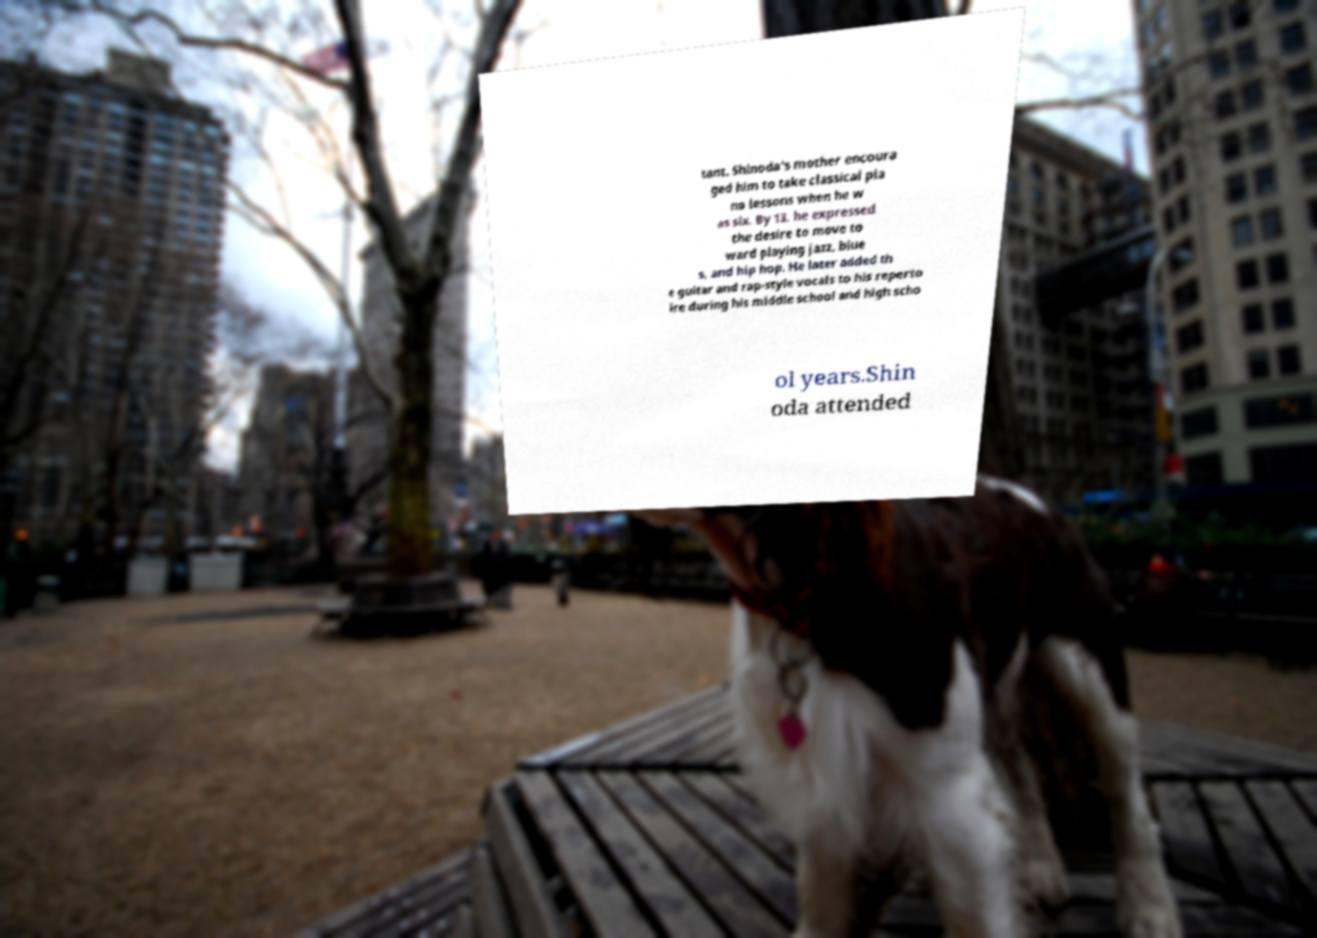For documentation purposes, I need the text within this image transcribed. Could you provide that? tant. Shinoda's mother encoura ged him to take classical pia no lessons when he w as six. By 13, he expressed the desire to move to ward playing jazz, blue s, and hip hop. He later added th e guitar and rap-style vocals to his reperto ire during his middle school and high scho ol years.Shin oda attended 